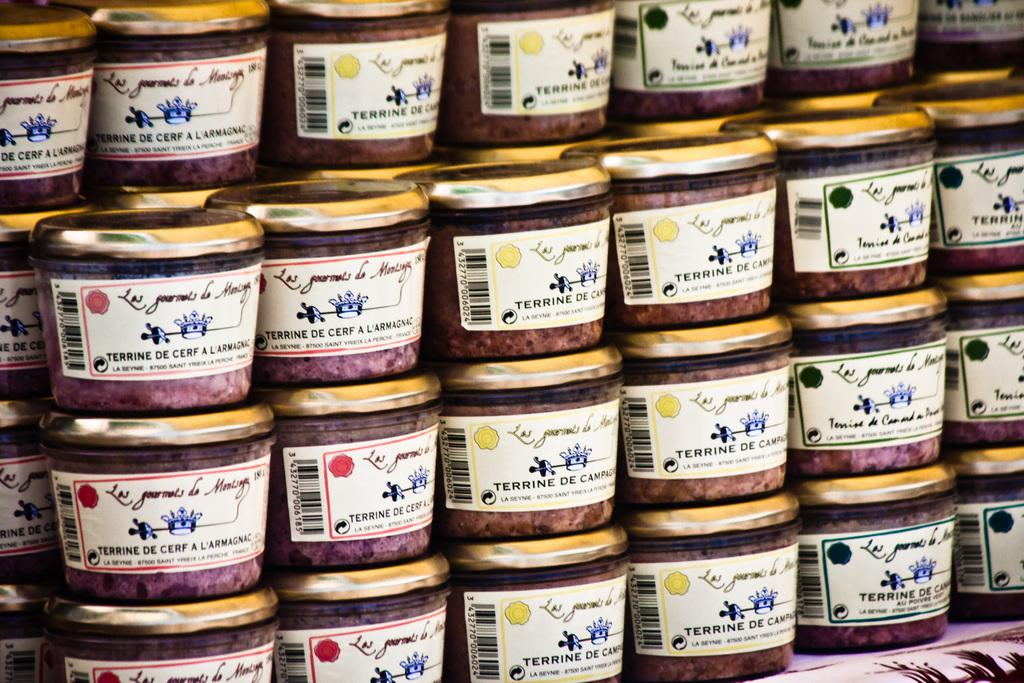<image>
Render a clear and concise summary of the photo. A series of Terrine De Cerf A Larmagnac jars stacked on top of each other. 